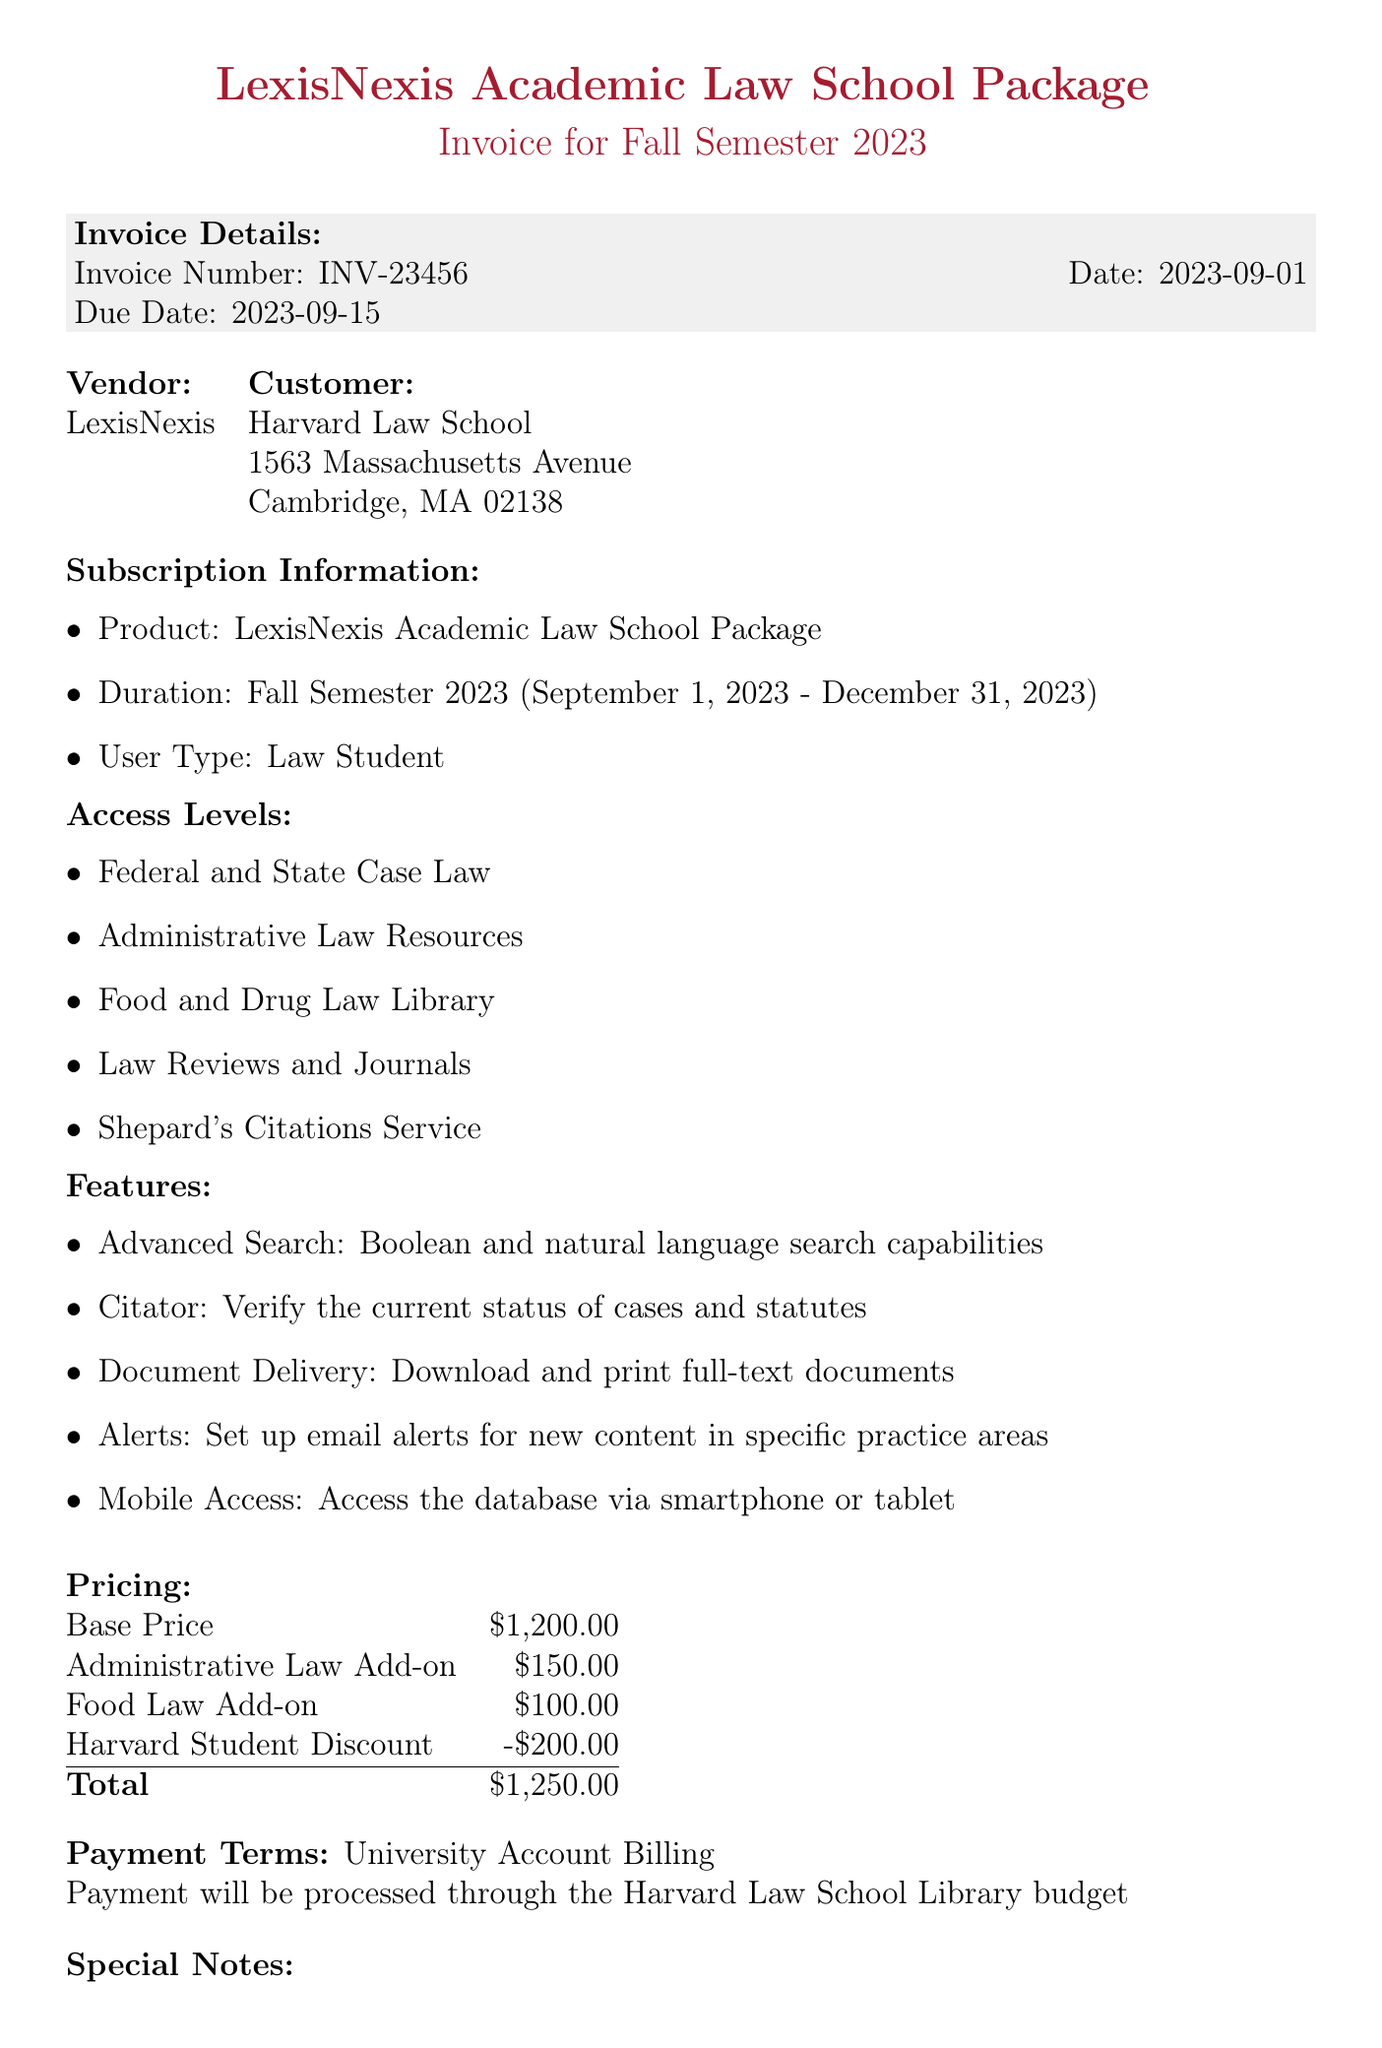what is the invoice number? The invoice number is listed in the document under invoice details.
Answer: INV-23456 what is the due date? The due date is specified in the invoice details section.
Answer: 2023-09-15 who is the vendor? The vendor's name is mentioned at the top of the invoice.
Answer: LexisNexis what is the total cost of the subscription? The total cost is the final amount computed in the pricing section of the document.
Answer: 1250.00 how many features are included in the subscription? The document lists the features that come with the subscription, which can be counted.
Answer: 5 what is one access level included with the subscription? The access levels are detailed in the access levels section; any one can be chosen as an answer.
Answer: Administrative Law Resources what is the product name? The product name is clearly stated in the subscription information section.
Answer: LexisNexis Academic Law School Package when does the subscription duration end? The end date of the subscription is mentioned in the duration detail.
Answer: December 31, 2023 what method is used for payment processing? The payment terms section specifies the payment method.
Answer: University Account Billing 